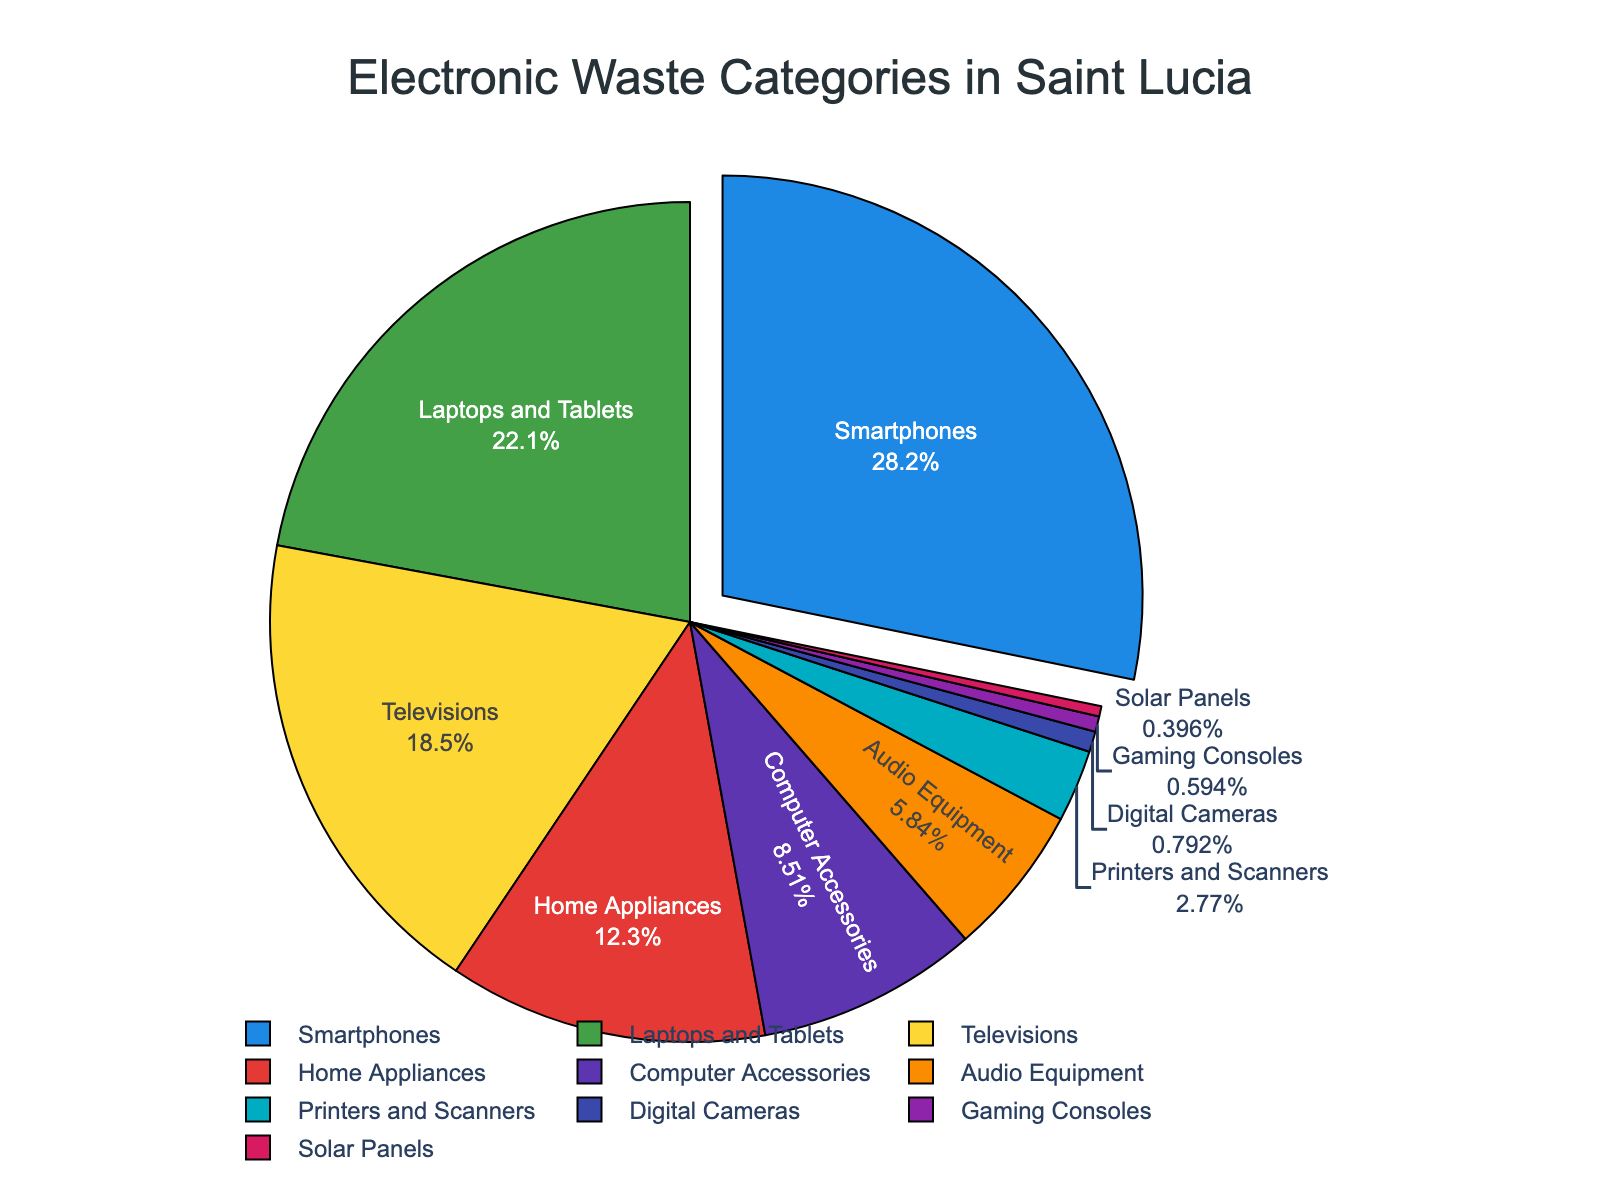How much electronic waste, in terms of percentage, is collected from smartphones? The figure shows that smartphones account for 28.5% of the total electronic waste collected.
Answer: 28.5% Which category contributes more to electronic waste: Home Appliances or Televisions? The figure shows that Home Appliances contribute 12.4% and Televisions contribute 18.7%. Since 18.7% > 12.4%, Televisions contribute more.
Answer: Televisions What is the combined percentage of electronic waste from Printers and Scanners, and Digital Cameras? According to the figure, Printers and Scanners account for 2.8% and Digital Cameras for 0.8%. Adding these together: 2.8% + 0.8% = 3.6%.
Answer: 3.6% Which category contributes the least to electronic waste? The figure indicates that Gaming Consoles contribute 0.6%, and Solar Panels contribute 0.4%. Since 0.4% is the smallest, Solar Panels contribute the least.
Answer: Solar Panels How does the percentage of waste from Computer Accessories compare to Audio Equipment? The figure shows Computer Accessories at 8.6% and Audio Equipment at 5.9%. Since 8.6% > 5.9%, Computer Accessories contribute more.
Answer: Computer Accessories What is the total percentage of electronic waste from Smart Devices (Smartphones and Laptops/Tablets)? From the figure, Smartphones are 28.5% and Laptops and Tablets are 22.3%. Adding these together: 28.5% + 22.3% = 50.8%.
Answer: 50.8% Is the percentage of waste from Home Appliances greater than the percentage from Gaming Consoles and Solar Panels combined? Home Appliances contribute 12.4%. Gaming Consoles and Solar Panels together contribute 0.6% + 0.4% = 1%. Since 12.4% > 1%, Home Appliances contribute more.
Answer: Yes What's the ratio of electronic waste from Smartphones to that from Printers and Scanners? The figure shows Smartphones at 28.5% and Printers and Scanners at 2.8%. The ratio is 28.5 / 2.8 ≈ 10.18.
Answer: 10.18 